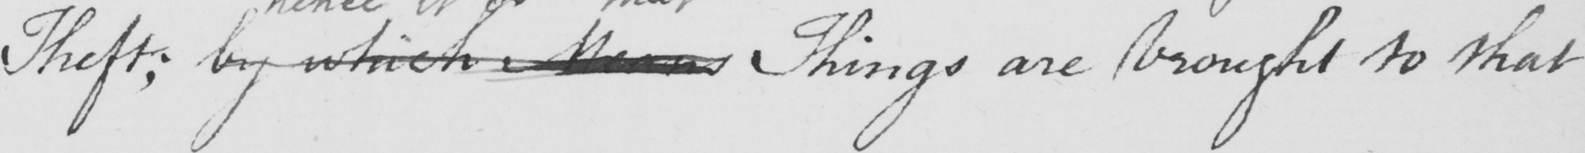What text is written in this handwritten line? Theft ; by which means Things are brought to that 